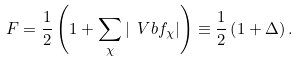Convert formula to latex. <formula><loc_0><loc_0><loc_500><loc_500>F = \frac { 1 } { 2 } \left ( 1 + \sum _ { \chi } | \ V b f _ { \chi } | \right ) \equiv \frac { 1 } { 2 } \left ( 1 + \Delta \right ) .</formula> 